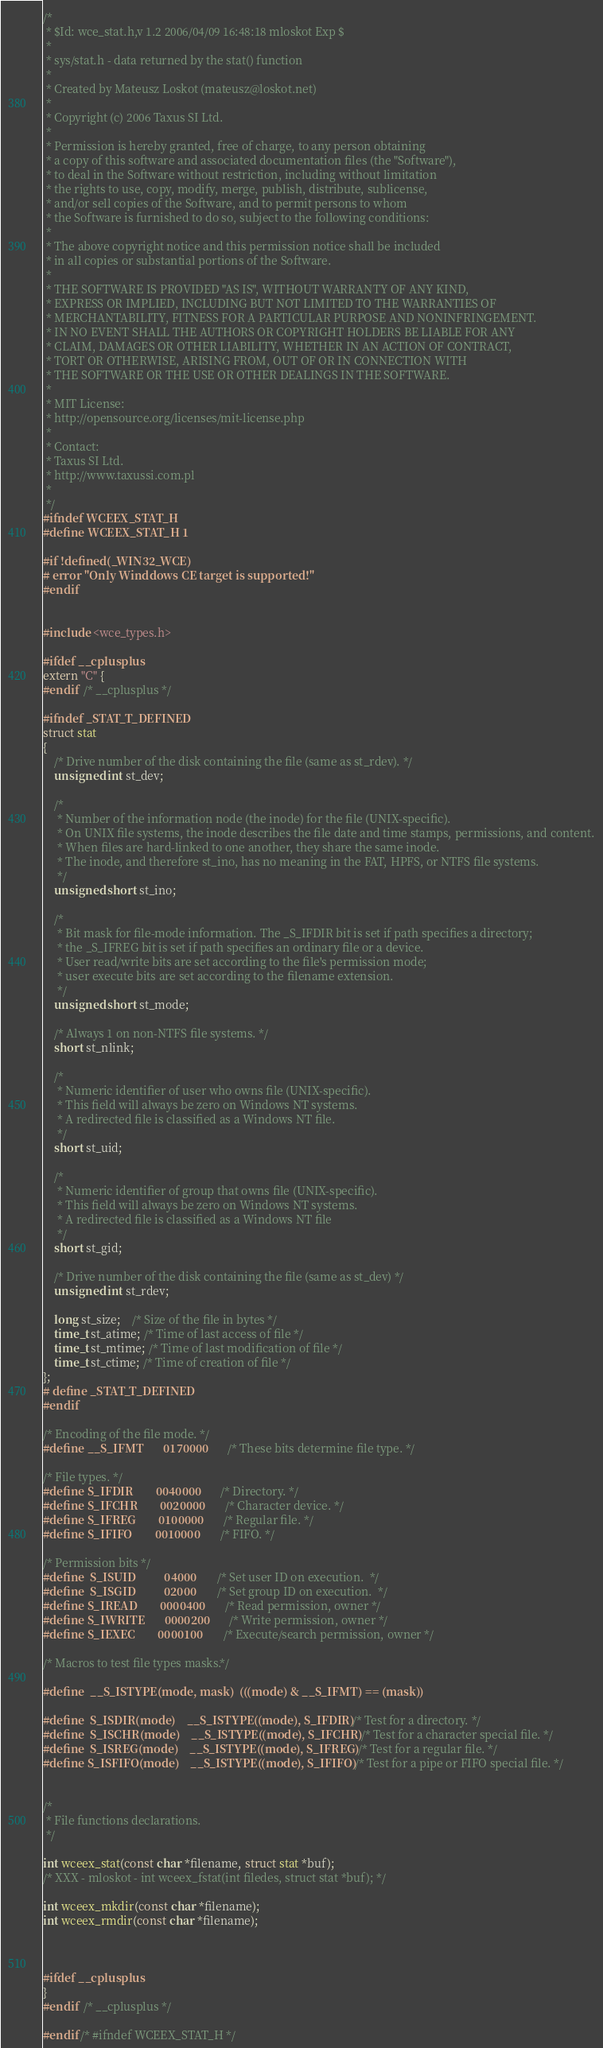Convert code to text. <code><loc_0><loc_0><loc_500><loc_500><_C_>/*
 * $Id: wce_stat.h,v 1.2 2006/04/09 16:48:18 mloskot Exp $
 *
 * sys/stat.h - data returned by the stat() function
 *
 * Created by Mateusz Loskot (mateusz@loskot.net)
 *
 * Copyright (c) 2006 Taxus SI Ltd.
 *
 * Permission is hereby granted, free of charge, to any person obtaining
 * a copy of this software and associated documentation files (the "Software"),
 * to deal in the Software without restriction, including without limitation 
 * the rights to use, copy, modify, merge, publish, distribute, sublicense,
 * and/or sell copies of the Software, and to permit persons to whom 
 * the Software is furnished to do so, subject to the following conditions:
 * 
 * The above copyright notice and this permission notice shall be included
 * in all copies or substantial portions of the Software.
 *
 * THE SOFTWARE IS PROVIDED "AS IS", WITHOUT WARRANTY OF ANY KIND,
 * EXPRESS OR IMPLIED, INCLUDING BUT NOT LIMITED TO THE WARRANTIES OF
 * MERCHANTABILITY, FITNESS FOR A PARTICULAR PURPOSE AND NONINFRINGEMENT.
 * IN NO EVENT SHALL THE AUTHORS OR COPYRIGHT HOLDERS BE LIABLE FOR ANY
 * CLAIM, DAMAGES OR OTHER LIABILITY, WHETHER IN AN ACTION OF CONTRACT,
 * TORT OR OTHERWISE, ARISING FROM, OUT OF OR IN CONNECTION WITH
 * THE SOFTWARE OR THE USE OR OTHER DEALINGS IN THE SOFTWARE.
 *
 * MIT License:
 * http://opensource.org/licenses/mit-license.php
 *
 * Contact:
 * Taxus SI Ltd.
 * http://www.taxussi.com.pl
 *
 */
#ifndef WCEEX_STAT_H
#define WCEEX_STAT_H 1

#if !defined(_WIN32_WCE)
# error "Only Winddows CE target is supported!"
#endif


#include <wce_types.h>

#ifdef __cplusplus
extern "C" {
#endif  /* __cplusplus */

#ifndef _STAT_T_DEFINED
struct stat
{
	/* Drive number of the disk containing the file (same as st_rdev). */
	unsigned int st_dev;

	/*
     * Number of the information node (the inode) for the file (UNIX-specific).
     * On UNIX file systems, the inode describes the file date and time stamps, permissions, and content.
     * When files are hard-linked to one another, they share the same inode. 
     * The inode, and therefore st_ino, has no meaning in the FAT, HPFS, or NTFS file systems.
     */
	unsigned short st_ino;

	/*
     * Bit mask for file-mode information. The _S_IFDIR bit is set if path specifies a directory;
	 * the _S_IFREG bit is set if path specifies an ordinary file or a device. 
	 * User read/write bits are set according to the file's permission mode;
     * user execute bits are set according to the filename extension.
     */
    unsigned short st_mode;

	/* Always 1 on non-NTFS file systems. */
	short st_nlink;

	/*
     * Numeric identifier of user who owns file (UNIX-specific).
     * This field will always be zero on Windows NT systems.
	 * A redirected file is classified as a Windows NT file.
     */
	short st_uid;
	
    /*
     * Numeric identifier of group that owns file (UNIX-specific).
     * This field will always be zero on Windows NT systems.
     * A redirected file is classified as a Windows NT file
     */
	short st_gid;

	/* Drive number of the disk containing the file (same as st_dev) */
	unsigned int st_rdev;

	long st_size;    /* Size of the file in bytes */
	time_t st_atime; /* Time of last access of file */
	time_t st_mtime; /* Time of last modification of file */
	time_t st_ctime; /* Time of creation of file */
};
# define _STAT_T_DEFINED
#endif

/* Encoding of the file mode. */
#define __S_IFMT       0170000         /* These bits determine file type. */

/* File types. */
#define S_IFDIR        0040000         /* Directory. */
#define S_IFCHR        0020000         /* Character device. */
#define S_IFREG        0100000         /* Regular file. */
#define S_IFIFO        0010000         /* FIFO. */

/* Permission bits */
#define	S_ISUID	         04000	       /* Set user ID on execution.  */
#define	S_ISGID	         02000	       /* Set group ID on execution.  */ 
#define S_IREAD        0000400         /* Read permission, owner */
#define S_IWRITE       0000200         /* Write permission, owner */
#define S_IEXEC        0000100         /* Execute/search permission, owner */

/* Macros to test file types masks.*/

#define	__S_ISTYPE(mode, mask)	(((mode) & __S_IFMT) == (mask))

#define	S_ISDIR(mode)	 __S_ISTYPE((mode), S_IFDIR)    /* Test for a directory. */
#define	S_ISCHR(mode)	 __S_ISTYPE((mode), S_IFCHR)    /* Test for a character special file. */
#define	S_ISREG(mode)	 __S_ISTYPE((mode), S_IFREG)    /* Test for a regular file. */
#define S_ISFIFO(mode)	 __S_ISTYPE((mode), S_IFIFO)    /* Test for a pipe or FIFO special file. */


/*
 * File functions declarations.
 */

int wceex_stat(const char *filename, struct stat *buf);
/* XXX - mloskot - int wceex_fstat(int filedes, struct stat *buf); */

int wceex_mkdir(const char *filename);
int wceex_rmdir(const char *filename);



#ifdef __cplusplus
}
#endif  /* __cplusplus */

#endif /* #ifndef WCEEX_STAT_H */
</code> 